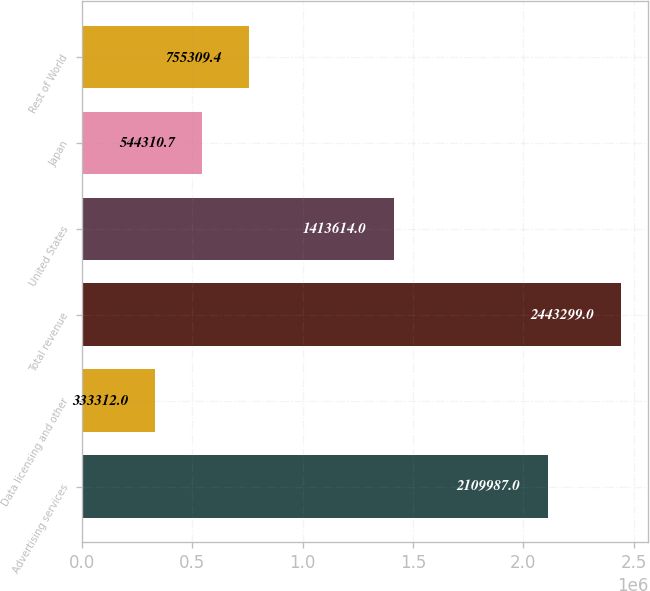Convert chart to OTSL. <chart><loc_0><loc_0><loc_500><loc_500><bar_chart><fcel>Advertising services<fcel>Data licensing and other<fcel>Total revenue<fcel>United States<fcel>Japan<fcel>Rest of World<nl><fcel>2.10999e+06<fcel>333312<fcel>2.4433e+06<fcel>1.41361e+06<fcel>544311<fcel>755309<nl></chart> 